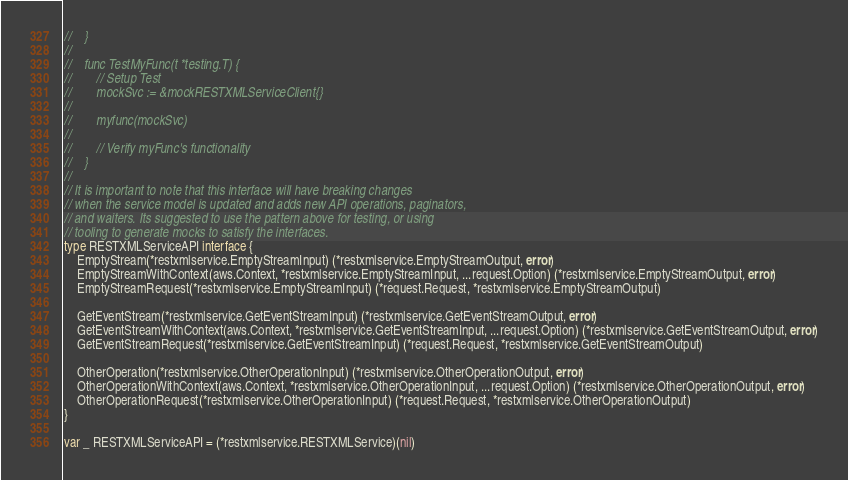Convert code to text. <code><loc_0><loc_0><loc_500><loc_500><_Go_>//    }
//
//    func TestMyFunc(t *testing.T) {
//        // Setup Test
//        mockSvc := &mockRESTXMLServiceClient{}
//
//        myfunc(mockSvc)
//
//        // Verify myFunc's functionality
//    }
//
// It is important to note that this interface will have breaking changes
// when the service model is updated and adds new API operations, paginators,
// and waiters. Its suggested to use the pattern above for testing, or using
// tooling to generate mocks to satisfy the interfaces.
type RESTXMLServiceAPI interface {
	EmptyStream(*restxmlservice.EmptyStreamInput) (*restxmlservice.EmptyStreamOutput, error)
	EmptyStreamWithContext(aws.Context, *restxmlservice.EmptyStreamInput, ...request.Option) (*restxmlservice.EmptyStreamOutput, error)
	EmptyStreamRequest(*restxmlservice.EmptyStreamInput) (*request.Request, *restxmlservice.EmptyStreamOutput)

	GetEventStream(*restxmlservice.GetEventStreamInput) (*restxmlservice.GetEventStreamOutput, error)
	GetEventStreamWithContext(aws.Context, *restxmlservice.GetEventStreamInput, ...request.Option) (*restxmlservice.GetEventStreamOutput, error)
	GetEventStreamRequest(*restxmlservice.GetEventStreamInput) (*request.Request, *restxmlservice.GetEventStreamOutput)

	OtherOperation(*restxmlservice.OtherOperationInput) (*restxmlservice.OtherOperationOutput, error)
	OtherOperationWithContext(aws.Context, *restxmlservice.OtherOperationInput, ...request.Option) (*restxmlservice.OtherOperationOutput, error)
	OtherOperationRequest(*restxmlservice.OtherOperationInput) (*request.Request, *restxmlservice.OtherOperationOutput)
}

var _ RESTXMLServiceAPI = (*restxmlservice.RESTXMLService)(nil)
</code> 